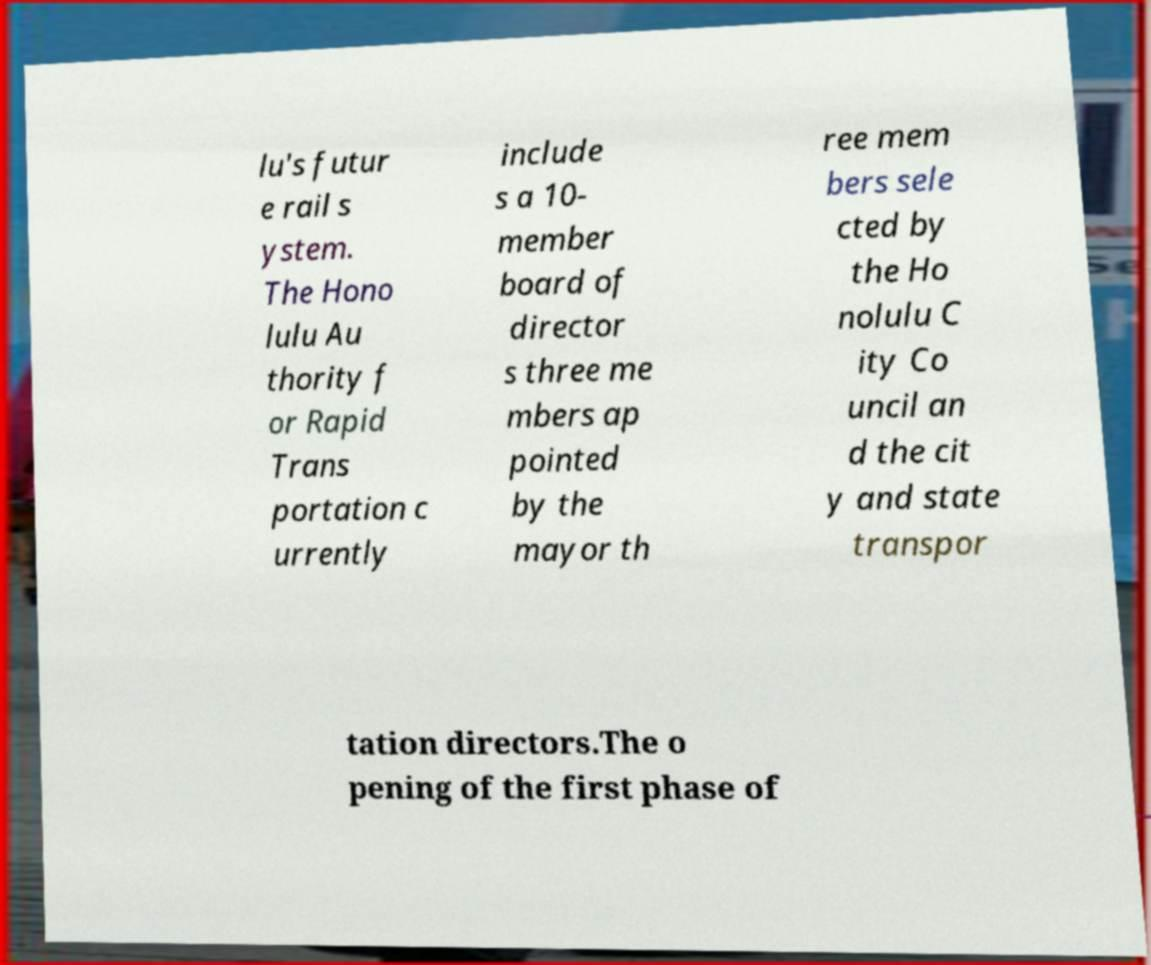What messages or text are displayed in this image? I need them in a readable, typed format. lu's futur e rail s ystem. The Hono lulu Au thority f or Rapid Trans portation c urrently include s a 10- member board of director s three me mbers ap pointed by the mayor th ree mem bers sele cted by the Ho nolulu C ity Co uncil an d the cit y and state transpor tation directors.The o pening of the first phase of 